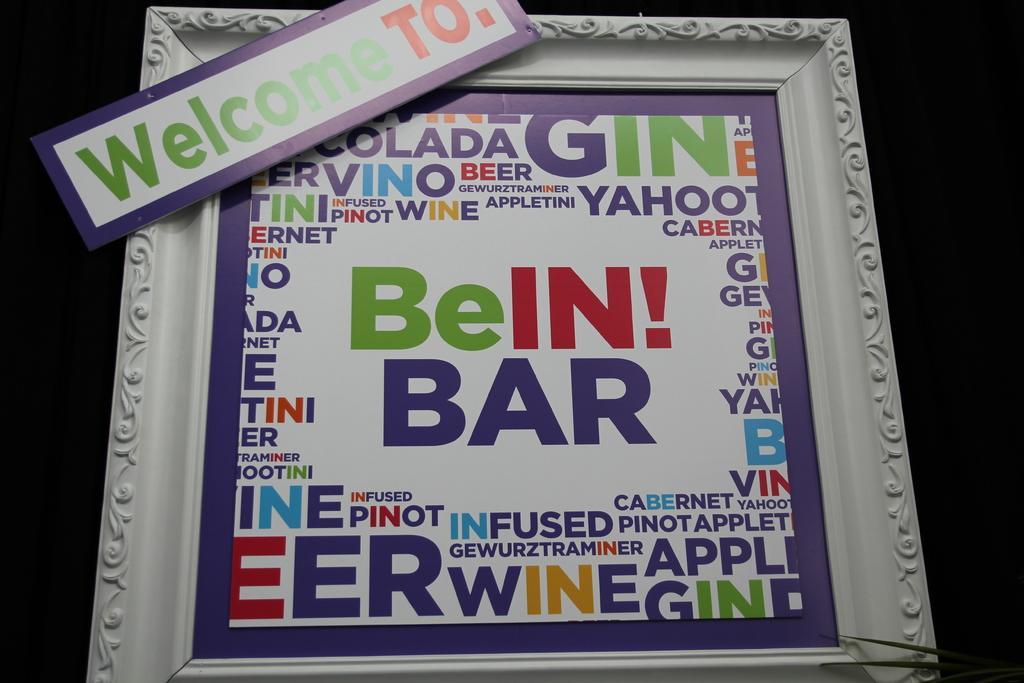<image>
Offer a succinct explanation of the picture presented. A white picture frame  with a banner on it that says Welcome to on it. 